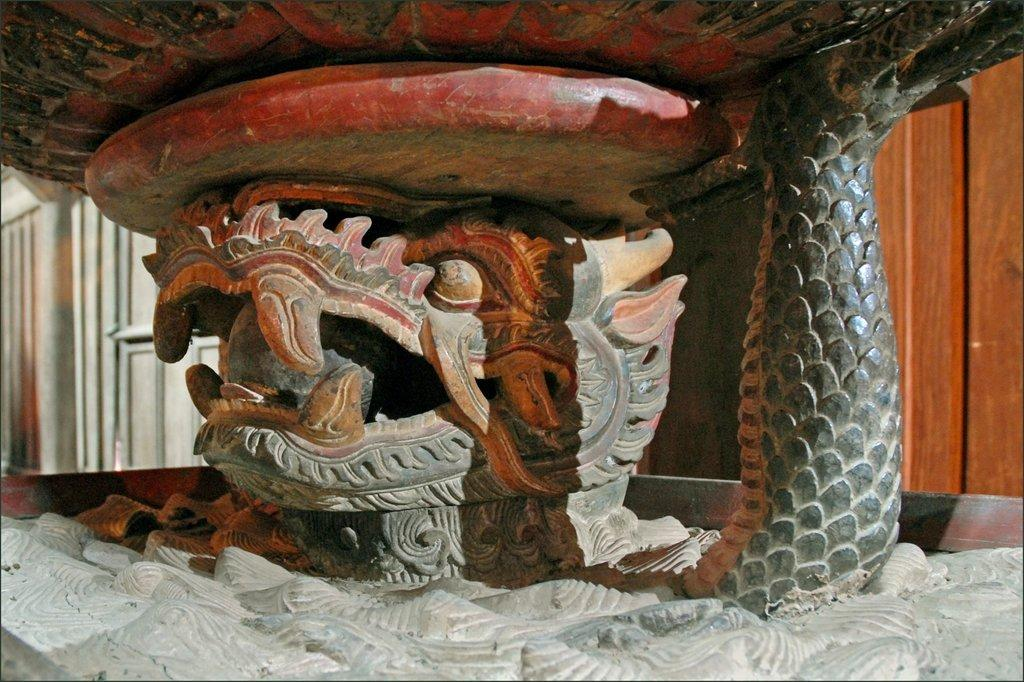What is the main subject of the image? The main subject of the image is a sculpture. What colors can be seen on the sculpture? The sculpture has red, black, and white colors. What type of cream is being used to paint the sculpture in the image? There is no cream being used to paint the sculpture in the image; the sculpture has red, black, and white colors. Is there a house visible in the image? There is no mention of a house in the provided facts, so we cannot determine if one is present in the image. 